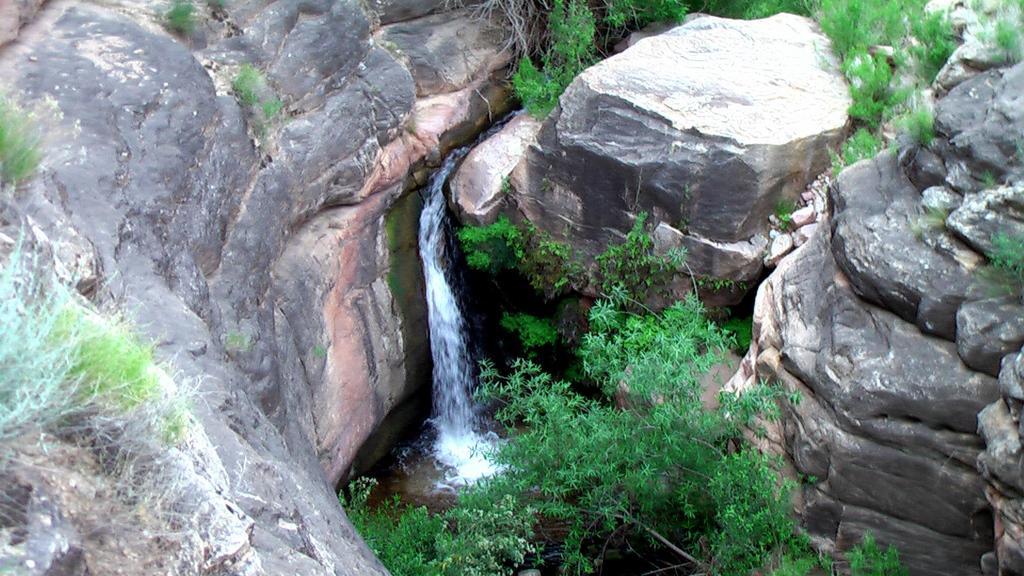Please provide a concise description of this image. In the center of the image we can see trees, grass, hills, water etc. 